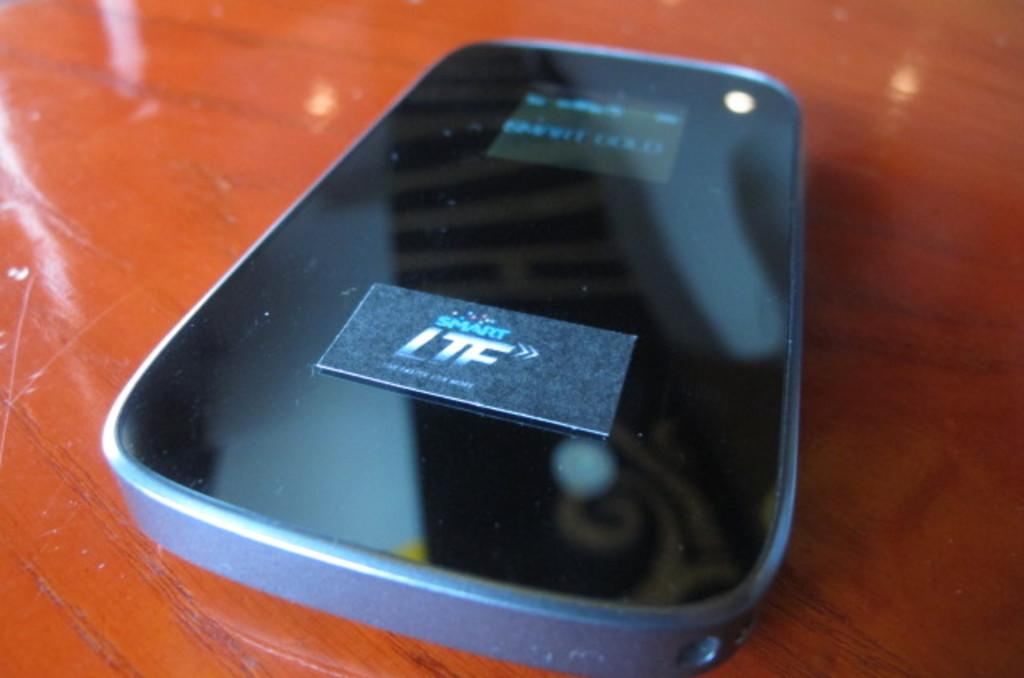<image>
Describe the image concisely. A phone in he table with a Smart LTE chip on top. 